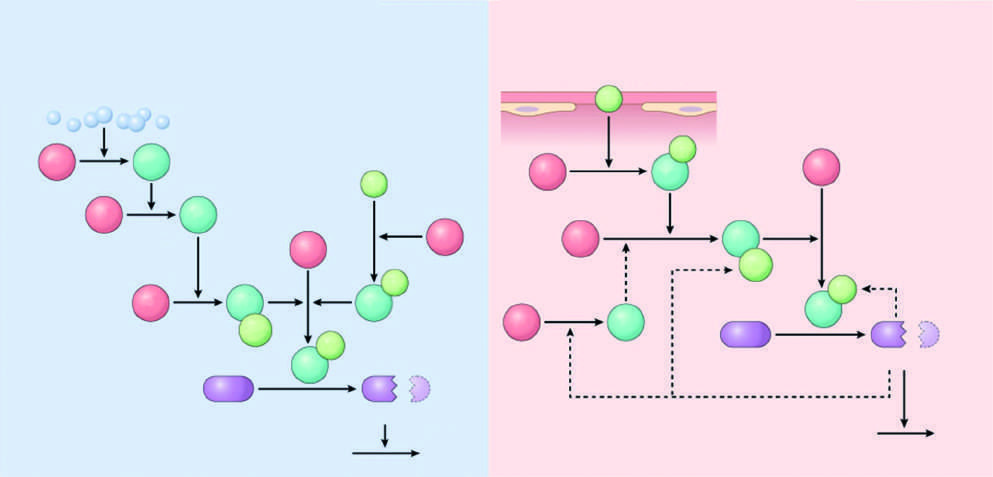what correspond to cofactors?
Answer the question using a single word or phrase. The light green polypeptides 